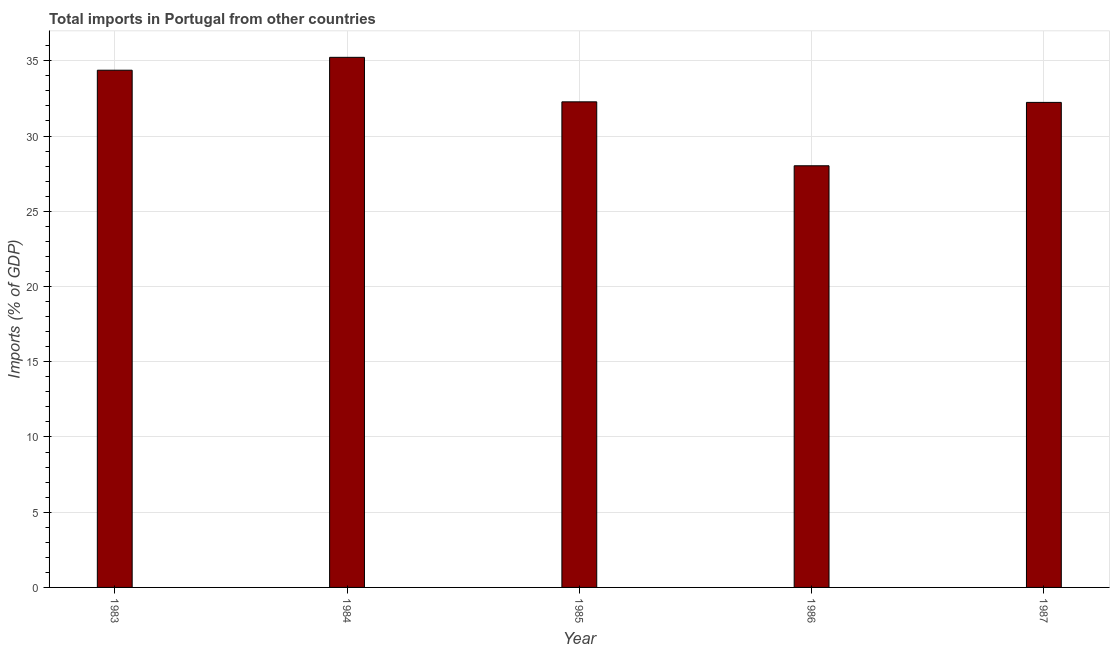What is the title of the graph?
Offer a terse response. Total imports in Portugal from other countries. What is the label or title of the X-axis?
Offer a very short reply. Year. What is the label or title of the Y-axis?
Provide a succinct answer. Imports (% of GDP). What is the total imports in 1985?
Ensure brevity in your answer.  32.27. Across all years, what is the maximum total imports?
Your answer should be very brief. 35.23. Across all years, what is the minimum total imports?
Offer a very short reply. 28.02. What is the sum of the total imports?
Your answer should be compact. 162.13. What is the difference between the total imports in 1983 and 1985?
Give a very brief answer. 2.1. What is the average total imports per year?
Offer a very short reply. 32.43. What is the median total imports?
Your answer should be compact. 32.27. In how many years, is the total imports greater than 31 %?
Your response must be concise. 4. Do a majority of the years between 1986 and 1983 (inclusive) have total imports greater than 13 %?
Offer a very short reply. Yes. Is the total imports in 1985 less than that in 1987?
Your answer should be very brief. No. What is the difference between the highest and the second highest total imports?
Your response must be concise. 0.86. What is the difference between the highest and the lowest total imports?
Keep it short and to the point. 7.21. Are all the bars in the graph horizontal?
Keep it short and to the point. No. Are the values on the major ticks of Y-axis written in scientific E-notation?
Give a very brief answer. No. What is the Imports (% of GDP) in 1983?
Give a very brief answer. 34.37. What is the Imports (% of GDP) of 1984?
Provide a succinct answer. 35.23. What is the Imports (% of GDP) of 1985?
Offer a terse response. 32.27. What is the Imports (% of GDP) of 1986?
Offer a very short reply. 28.02. What is the Imports (% of GDP) of 1987?
Keep it short and to the point. 32.23. What is the difference between the Imports (% of GDP) in 1983 and 1984?
Keep it short and to the point. -0.86. What is the difference between the Imports (% of GDP) in 1983 and 1985?
Keep it short and to the point. 2.1. What is the difference between the Imports (% of GDP) in 1983 and 1986?
Ensure brevity in your answer.  6.35. What is the difference between the Imports (% of GDP) in 1983 and 1987?
Make the answer very short. 2.14. What is the difference between the Imports (% of GDP) in 1984 and 1985?
Provide a short and direct response. 2.96. What is the difference between the Imports (% of GDP) in 1984 and 1986?
Ensure brevity in your answer.  7.21. What is the difference between the Imports (% of GDP) in 1984 and 1987?
Offer a terse response. 2.99. What is the difference between the Imports (% of GDP) in 1985 and 1986?
Make the answer very short. 4.25. What is the difference between the Imports (% of GDP) in 1985 and 1987?
Ensure brevity in your answer.  0.04. What is the difference between the Imports (% of GDP) in 1986 and 1987?
Ensure brevity in your answer.  -4.21. What is the ratio of the Imports (% of GDP) in 1983 to that in 1984?
Ensure brevity in your answer.  0.98. What is the ratio of the Imports (% of GDP) in 1983 to that in 1985?
Offer a terse response. 1.06. What is the ratio of the Imports (% of GDP) in 1983 to that in 1986?
Your answer should be very brief. 1.23. What is the ratio of the Imports (% of GDP) in 1983 to that in 1987?
Your answer should be very brief. 1.07. What is the ratio of the Imports (% of GDP) in 1984 to that in 1985?
Offer a terse response. 1.09. What is the ratio of the Imports (% of GDP) in 1984 to that in 1986?
Offer a terse response. 1.26. What is the ratio of the Imports (% of GDP) in 1984 to that in 1987?
Your answer should be very brief. 1.09. What is the ratio of the Imports (% of GDP) in 1985 to that in 1986?
Keep it short and to the point. 1.15. What is the ratio of the Imports (% of GDP) in 1986 to that in 1987?
Give a very brief answer. 0.87. 